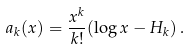Convert formula to latex. <formula><loc_0><loc_0><loc_500><loc_500>a _ { k } ( x ) = \frac { x ^ { k } } { k ! } ( \log x - H _ { k } ) \, .</formula> 